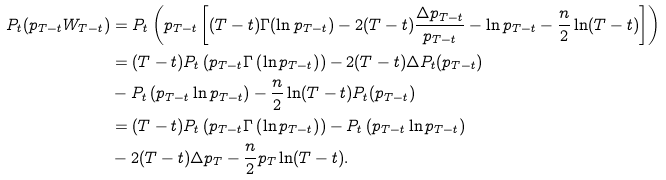Convert formula to latex. <formula><loc_0><loc_0><loc_500><loc_500>P _ { t } ( p _ { T - t } W _ { T - t } ) & = P _ { t } \left ( p _ { T - t } \left [ ( T - t ) \Gamma ( \ln p _ { T - t } ) - 2 ( T - t ) \frac { \Delta p _ { T - t } } { p _ { T - t } } - \ln p _ { T - t } - \frac { n } { 2 } \ln ( T - t ) \right ] \right ) \\ & = ( T - t ) P _ { t } \left ( p _ { T - t } \Gamma \left ( \ln p _ { T - t } \right ) \right ) - 2 ( T - t ) \Delta P _ { t } ( p _ { T - t } ) \\ & - P _ { t } \left ( p _ { T - t } \ln p _ { T - t } \right ) - \frac { n } { 2 } \ln ( T - t ) P _ { t } ( p _ { T - t } ) \\ & = ( T - t ) P _ { t } \left ( p _ { T - t } \Gamma \left ( \ln p _ { T - t } \right ) \right ) - P _ { t } \left ( p _ { T - t } \ln p _ { T - t } \right ) \\ & - 2 ( T - t ) \Delta p _ { T } - \frac { n } { 2 } p _ { T } \ln ( T - t ) .</formula> 